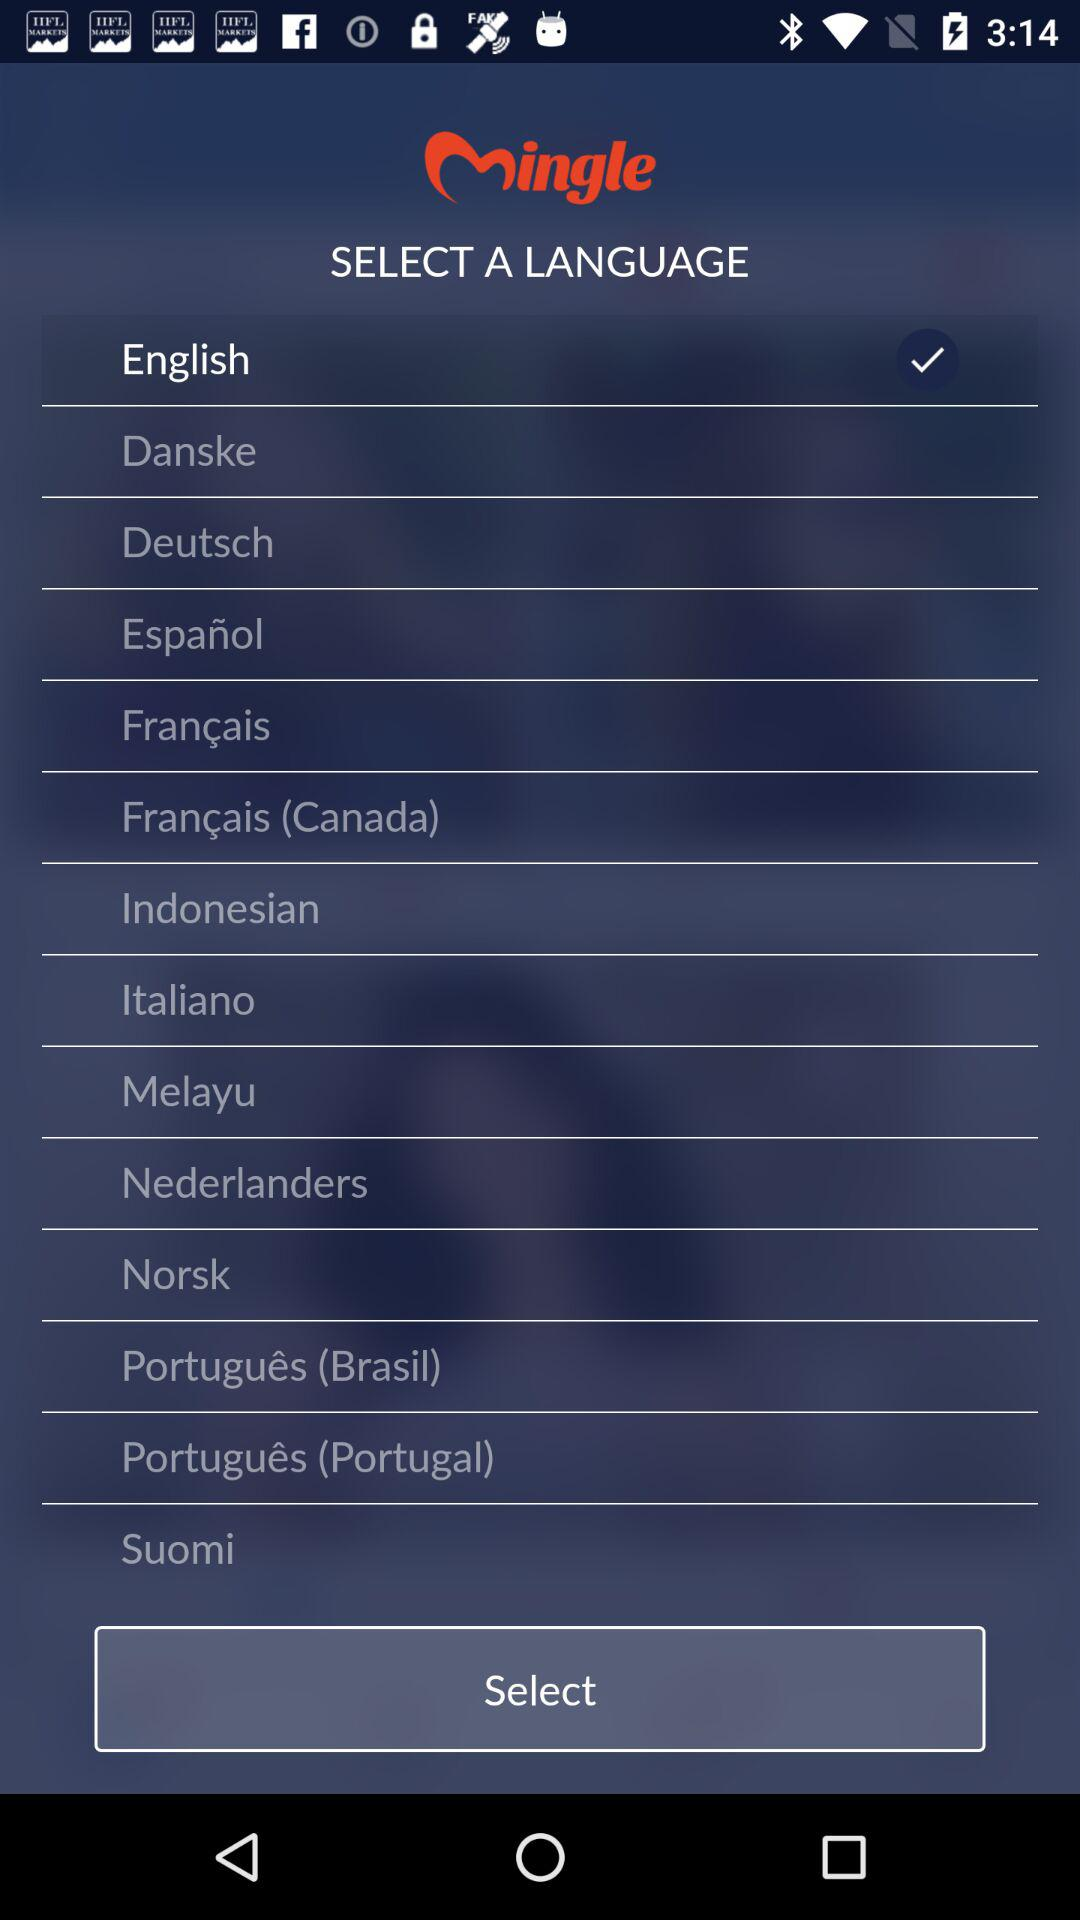When was "Mingle" last updated?
When the provided information is insufficient, respond with <no answer>. <no answer> 